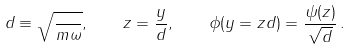<formula> <loc_0><loc_0><loc_500><loc_500>d \equiv \sqrt { \frac { } { m \omega } } , \quad z = \frac { y } { d } , \quad \phi ( y = z d ) = \frac { \psi { ( z ) } } { \sqrt { d } } \, .</formula> 